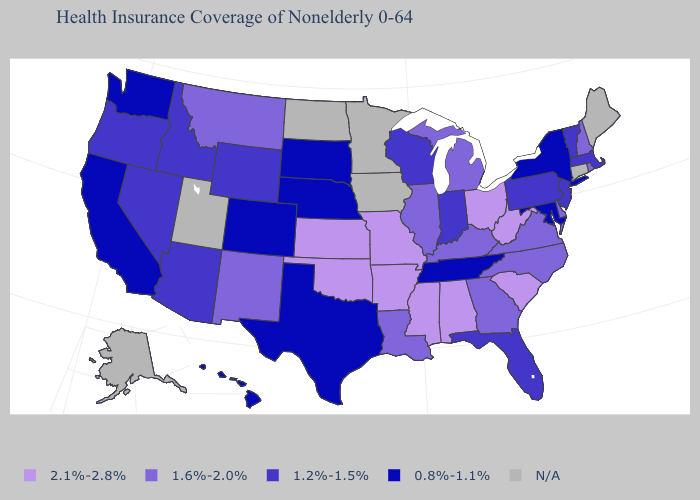What is the value of Delaware?
Short answer required. 1.6%-2.0%. Among the states that border Arkansas , which have the lowest value?
Short answer required. Tennessee, Texas. Which states have the highest value in the USA?
Be succinct. Alabama, Arkansas, Kansas, Mississippi, Missouri, Ohio, Oklahoma, South Carolina, West Virginia. What is the value of Ohio?
Write a very short answer. 2.1%-2.8%. Does the map have missing data?
Be succinct. Yes. Name the states that have a value in the range 2.1%-2.8%?
Give a very brief answer. Alabama, Arkansas, Kansas, Mississippi, Missouri, Ohio, Oklahoma, South Carolina, West Virginia. Is the legend a continuous bar?
Be succinct. No. What is the value of Alaska?
Quick response, please. N/A. Which states have the lowest value in the MidWest?
Quick response, please. Nebraska, South Dakota. What is the lowest value in the MidWest?
Answer briefly. 0.8%-1.1%. Which states hav the highest value in the Northeast?
Give a very brief answer. New Hampshire, Rhode Island. Does New York have the lowest value in the Northeast?
Write a very short answer. Yes. Does the map have missing data?
Keep it brief. Yes. Name the states that have a value in the range 1.6%-2.0%?
Concise answer only. Delaware, Georgia, Illinois, Kentucky, Louisiana, Michigan, Montana, New Hampshire, New Mexico, North Carolina, Rhode Island, Virginia. Does Kansas have the highest value in the MidWest?
Give a very brief answer. Yes. 